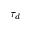<formula> <loc_0><loc_0><loc_500><loc_500>\tau _ { d }</formula> 